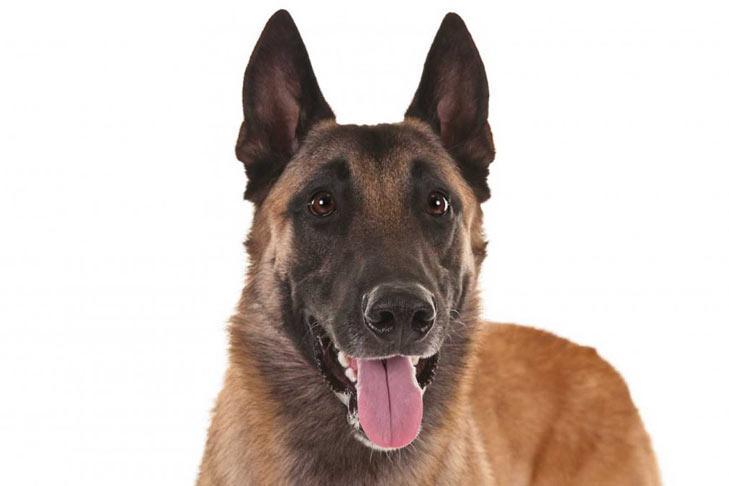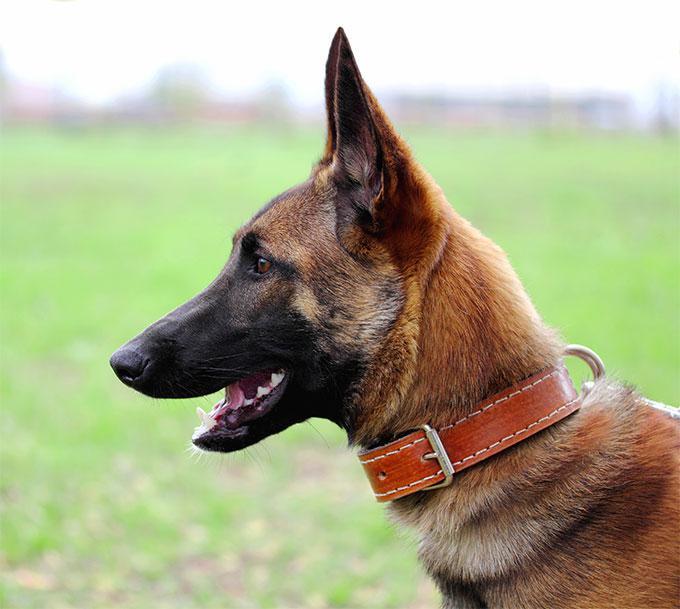The first image is the image on the left, the second image is the image on the right. Assess this claim about the two images: "An image shows a german shepherd wearing a collar.". Correct or not? Answer yes or no. Yes. 